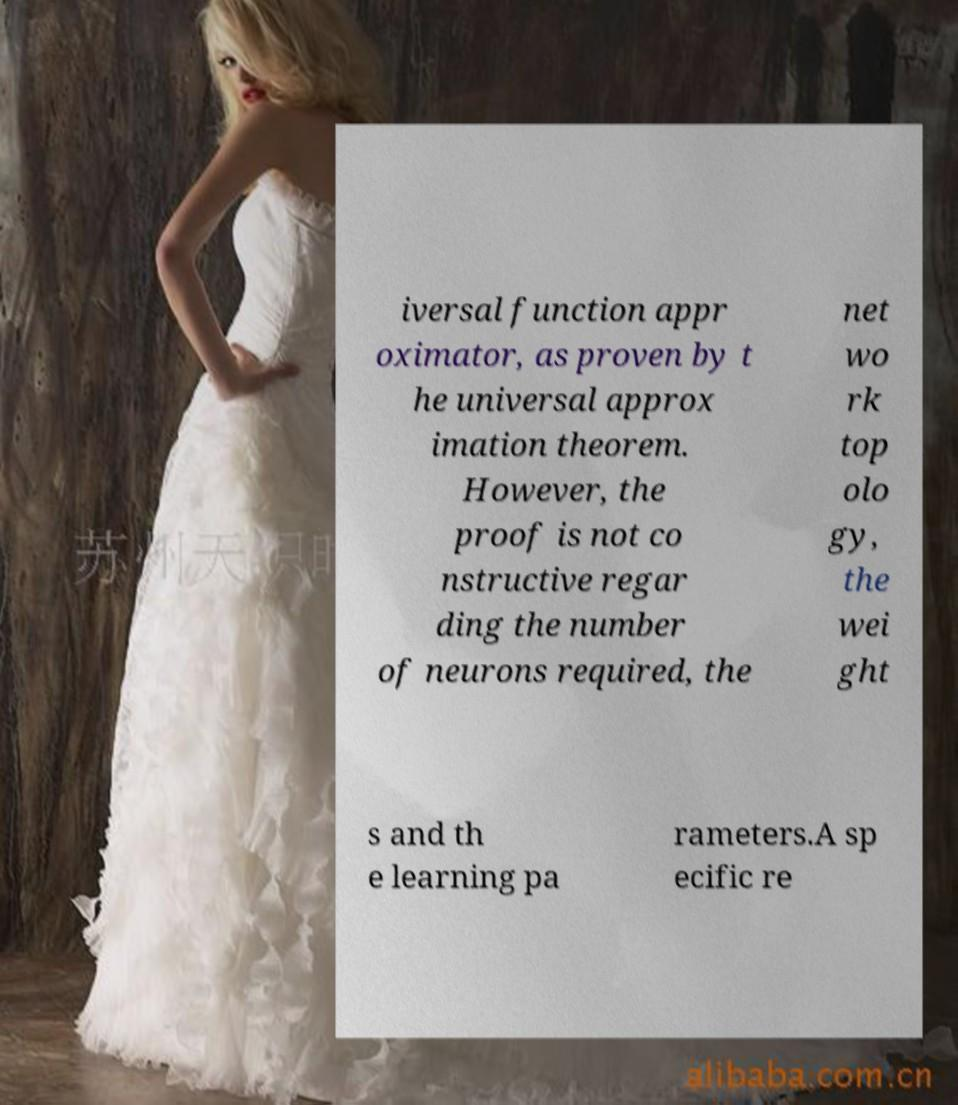Please identify and transcribe the text found in this image. iversal function appr oximator, as proven by t he universal approx imation theorem. However, the proof is not co nstructive regar ding the number of neurons required, the net wo rk top olo gy, the wei ght s and th e learning pa rameters.A sp ecific re 